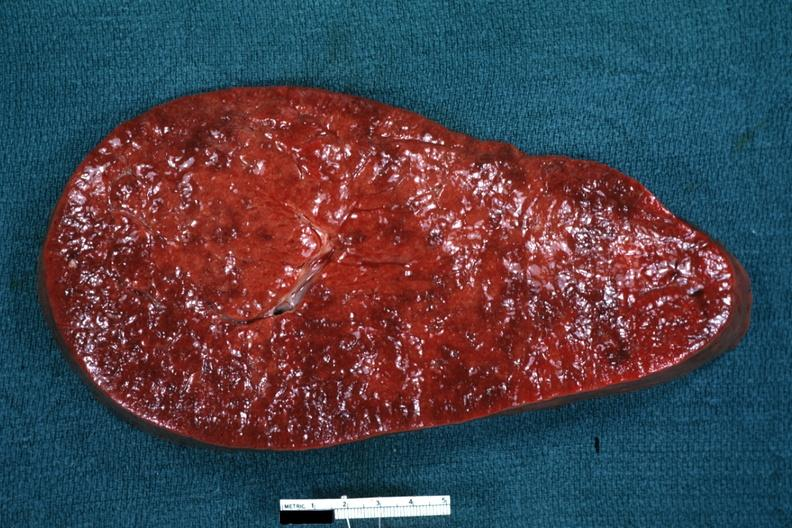what is present?
Answer the question using a single word or phrase. Myelomonocytic leukemia 